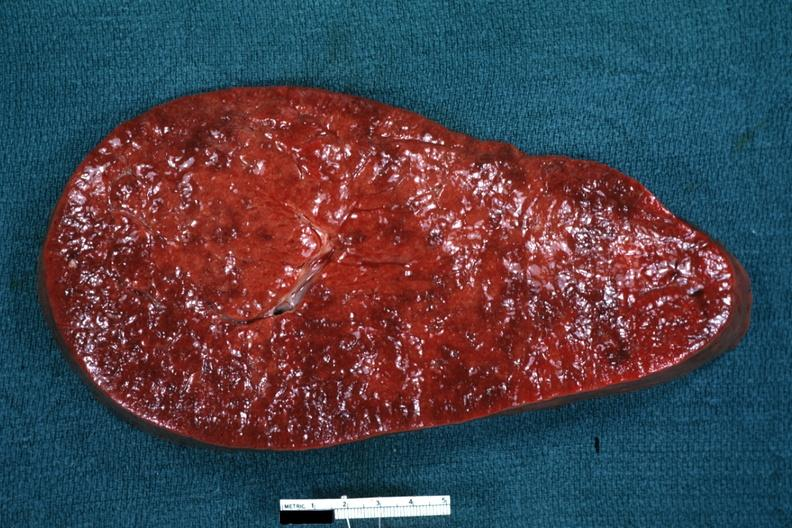what is present?
Answer the question using a single word or phrase. Myelomonocytic leukemia 